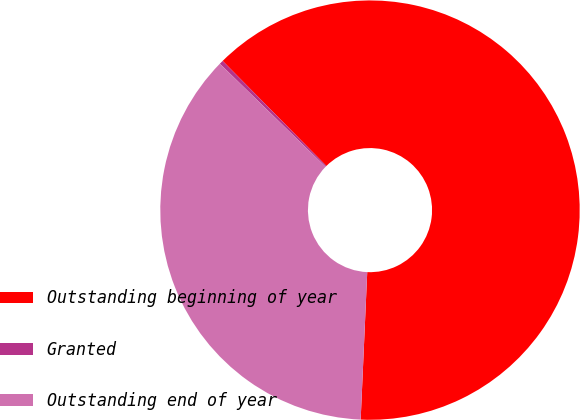<chart> <loc_0><loc_0><loc_500><loc_500><pie_chart><fcel>Outstanding beginning of year<fcel>Granted<fcel>Outstanding end of year<nl><fcel>63.11%<fcel>0.3%<fcel>36.59%<nl></chart> 